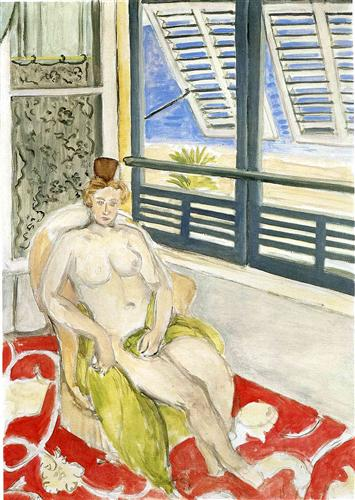Can you describe the technique the artist used in this painting? Certainly! The artist's technique here is indicative of post-impressionism and is characterized by loose brushwork, bright and unmixed colors, and a focus on the interplay between light and shadow. The use of broad, visible strokes adds texture to the composition and emphasizes the form and volume of the figure and objects. The technique demonstrates an exploration of color and its effect on conveying emotion, rather than a strict adherence to realistic depiction. 